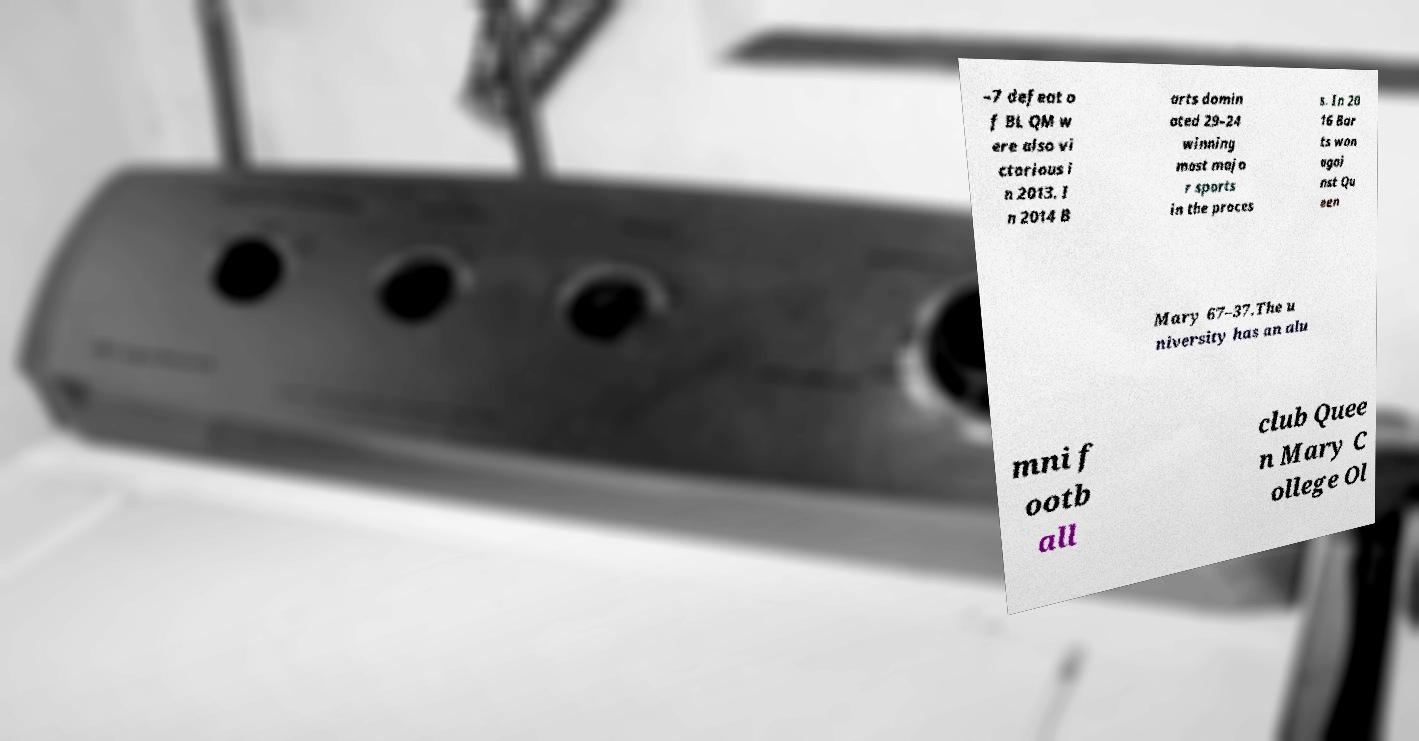Could you extract and type out the text from this image? –7 defeat o f BL QM w ere also vi ctorious i n 2013. I n 2014 B arts domin ated 29–24 winning most majo r sports in the proces s. In 20 16 Bar ts won agai nst Qu een Mary 67–37.The u niversity has an alu mni f ootb all club Quee n Mary C ollege Ol 